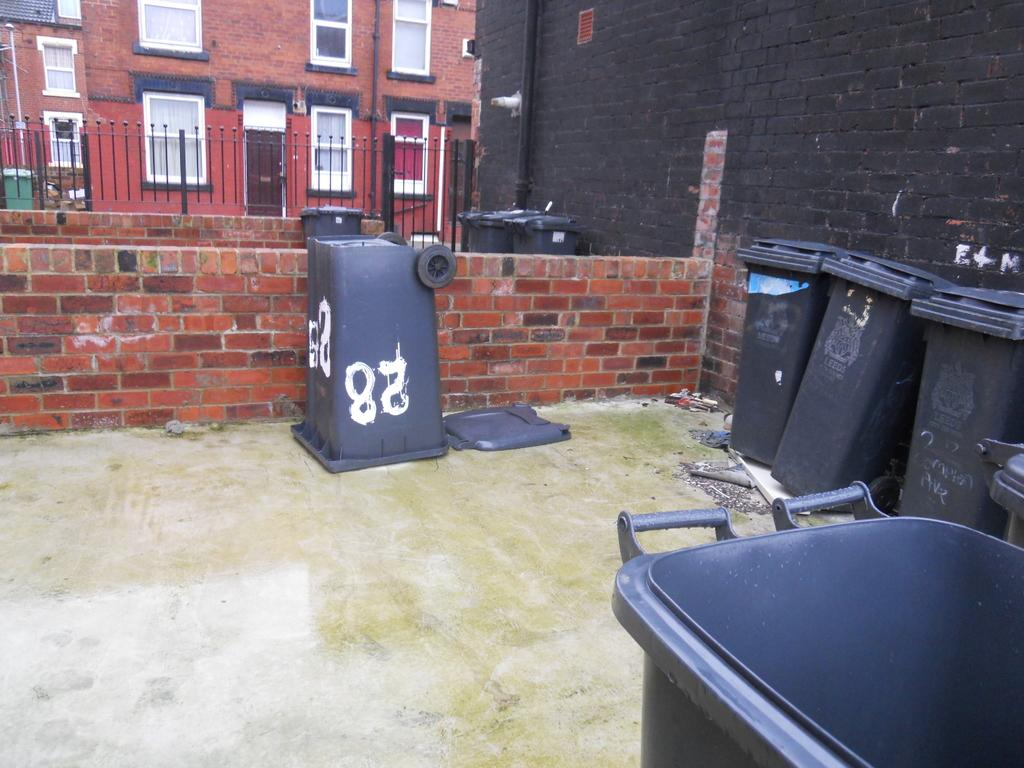<image>
Offer a succinct explanation of the picture presented. Garbage cans are placed in a courtyard type area with the number 28 painted on a garbage can that is upside down. 